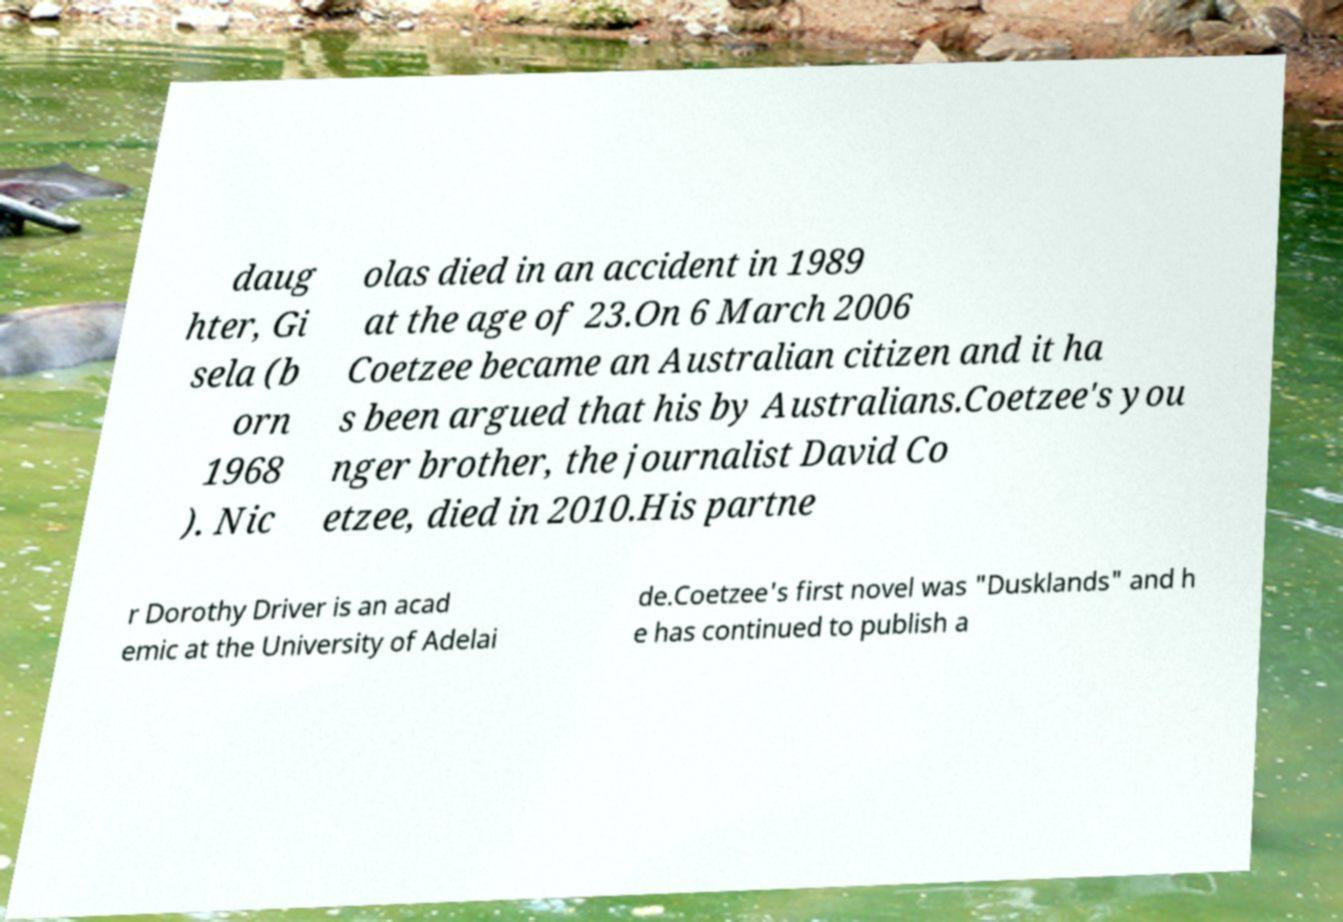Please read and relay the text visible in this image. What does it say? daug hter, Gi sela (b orn 1968 ). Nic olas died in an accident in 1989 at the age of 23.On 6 March 2006 Coetzee became an Australian citizen and it ha s been argued that his by Australians.Coetzee's you nger brother, the journalist David Co etzee, died in 2010.His partne r Dorothy Driver is an acad emic at the University of Adelai de.Coetzee's first novel was "Dusklands" and h e has continued to publish a 